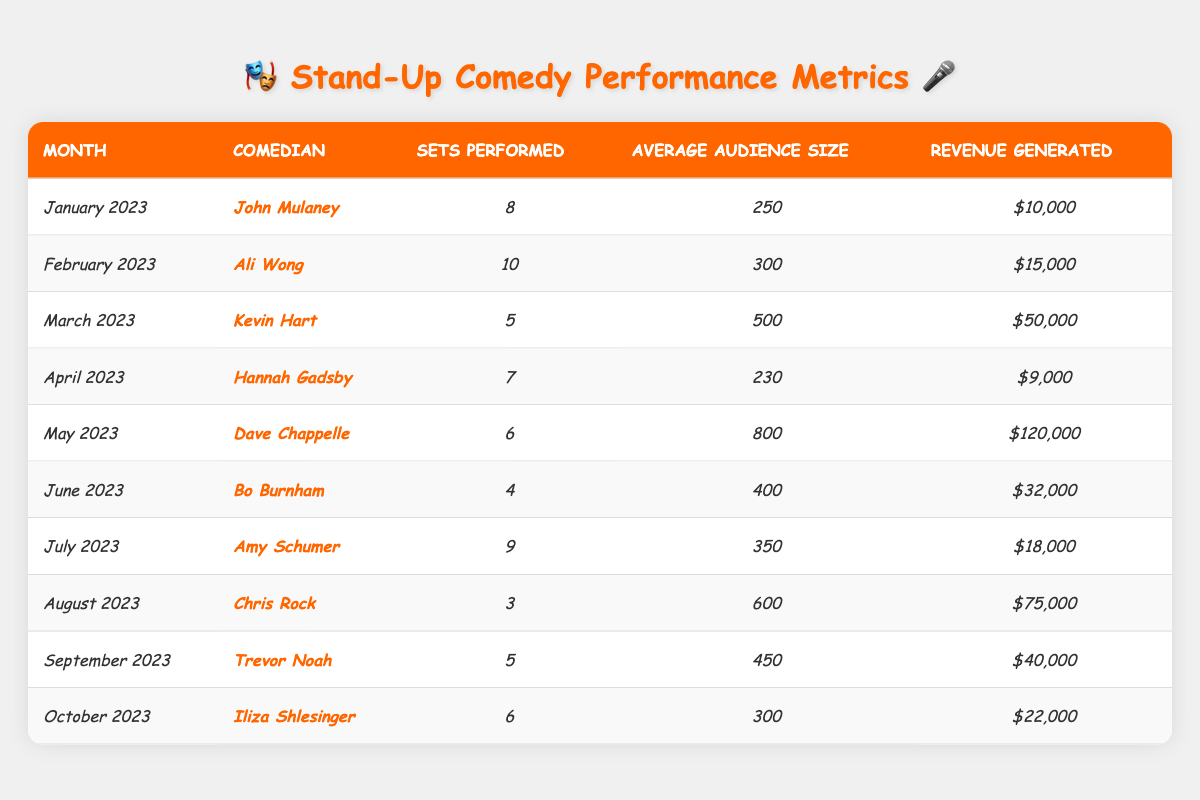What was the average audience size for John Mulaney in January 2023? The table shows that John Mulaney performed in January 2023 with an average audience size of 250.
Answer: 250 Which comedian had the highest revenue in a single month? By comparing the revenue generated by each comedian, Dave Chappelle had the highest revenue of $120,000 in May 2023.
Answer: $120,000 How many sets did Ali Wong perform more than Hannah Gadsby? Ali Wong performed 10 sets and Hannah Gadsby performed 7 sets. The difference is 10 - 7 = 3.
Answer: 3 What is the total revenue generated by all comedians in June, July, and August? The revenue for June is $32,000, July is $18,000, and August is $75,000. Summing these values gives $32,000 + $18,000 + $75,000 = $125,000.
Answer: $125,000 What percentage of the total sets performed in the year did Kevin Hart account for? Kevin Hart performed 5 sets. The total sets performed (summing all values) is 8 + 10 + 5 + 7 + 6 + 4 + 9 + 3 + 5 + 6 = 63. The percentage is (5/63) × 100 ≈ 7.94%.
Answer: ≈ 7.94% Which month had the lowest average audience size, and what was it? By checking the average audience sizes, April had the lowest at 230.
Answer: April, 230 True or False: Chris Rock performed more sets than Amy Schumer. Chris Rock performed 3 sets while Amy Schumer performed 9 sets, so the statement is false.
Answer: False What is the average revenue generated by all comedians in the table? The total revenue generated by all comedians is $10,000 + $15,000 + $50,000 + $9,000 + $120,000 + $32,000 + $18,000 + $75,000 + $40,000 + $22,000 = $321,000. There are 10 comedians, so the average is $321,000 / 10 = $32,100.
Answer: $32,100 Which comedian had the highest average audience size, and what was that size? By evaluating the average audience sizes, Dave Chappelle had the highest at 800.
Answer: Dave Chappelle, 800 How many total sets did all comedians perform over the year? By adding all the sets performed: 8 + 10 + 5 + 7 + 6 + 4 + 9 + 3 + 5 + 6 = 63.
Answer: 63 Which comedian generated more revenue, Trevor Noah or Iliza Shlesinger? Trevor Noah generated $40,000 while Iliza Shlesinger generated $22,000. Since $40,000 > $22,000, Trevor Noah generated more.
Answer: Trevor Noah 